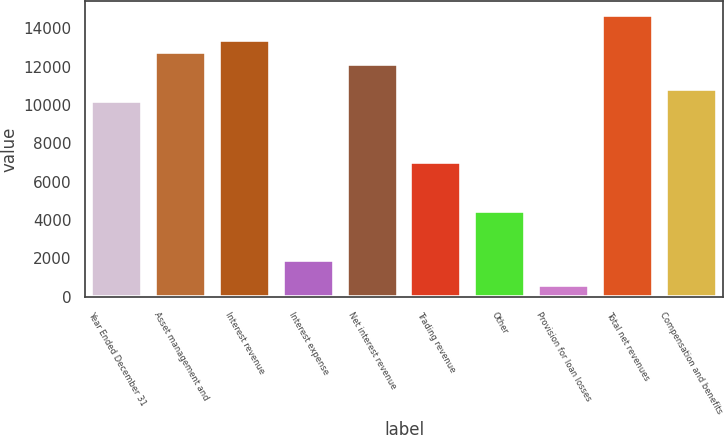<chart> <loc_0><loc_0><loc_500><loc_500><bar_chart><fcel>Year Ended December 31<fcel>Asset management and<fcel>Interest revenue<fcel>Interest expense<fcel>Net interest revenue<fcel>Trading revenue<fcel>Other<fcel>Provision for loan losses<fcel>Total net revenues<fcel>Compensation and benefits<nl><fcel>10207.9<fcel>12759.8<fcel>13397.8<fcel>1914.18<fcel>12121.9<fcel>7018.02<fcel>4466.1<fcel>638.22<fcel>14673.8<fcel>10845.9<nl></chart> 